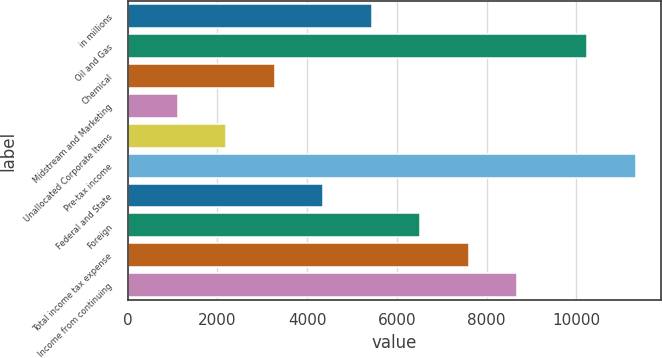<chart> <loc_0><loc_0><loc_500><loc_500><bar_chart><fcel>in millions<fcel>Oil and Gas<fcel>Chemical<fcel>Midstream and Marketing<fcel>Unallocated Corporate Items<fcel>Pre-tax income<fcel>Federal and State<fcel>Foreign<fcel>Total income tax expense<fcel>Income from continuing<nl><fcel>5440<fcel>10241<fcel>3279.6<fcel>1119.2<fcel>2199.4<fcel>11321.2<fcel>4359.8<fcel>6520.2<fcel>7600.4<fcel>8680.6<nl></chart> 